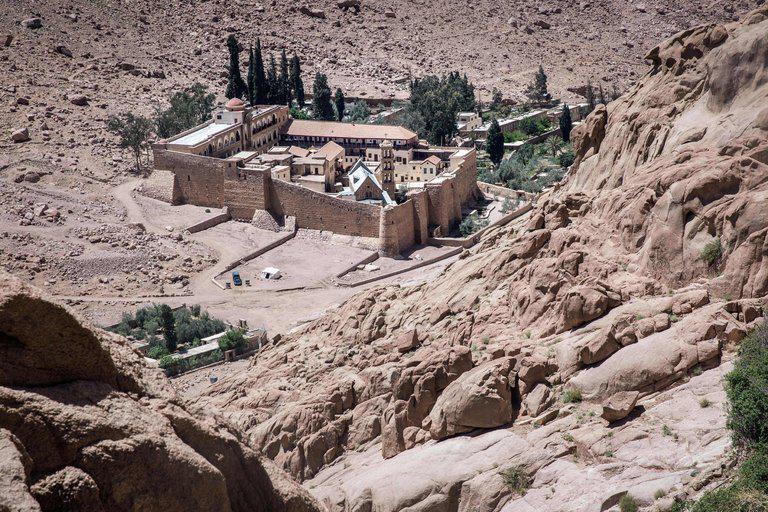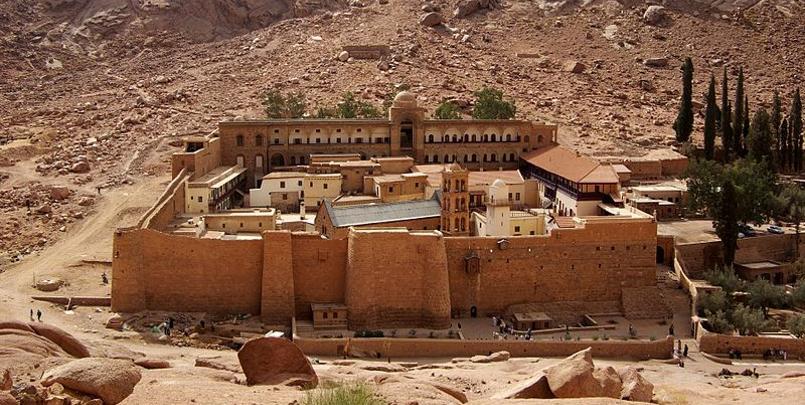The first image is the image on the left, the second image is the image on the right. Given the left and right images, does the statement "There is mountain in the bottom right of one image, next to and above the town, but not in the other image." hold true? Answer yes or no. Yes. 